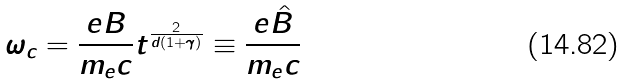Convert formula to latex. <formula><loc_0><loc_0><loc_500><loc_500>\omega _ { c } = \frac { e B } { m _ { e } c } t ^ { \frac { 2 } { d ( 1 + \gamma ) } } \equiv \frac { e \hat { B } } { m _ { e } c }</formula> 